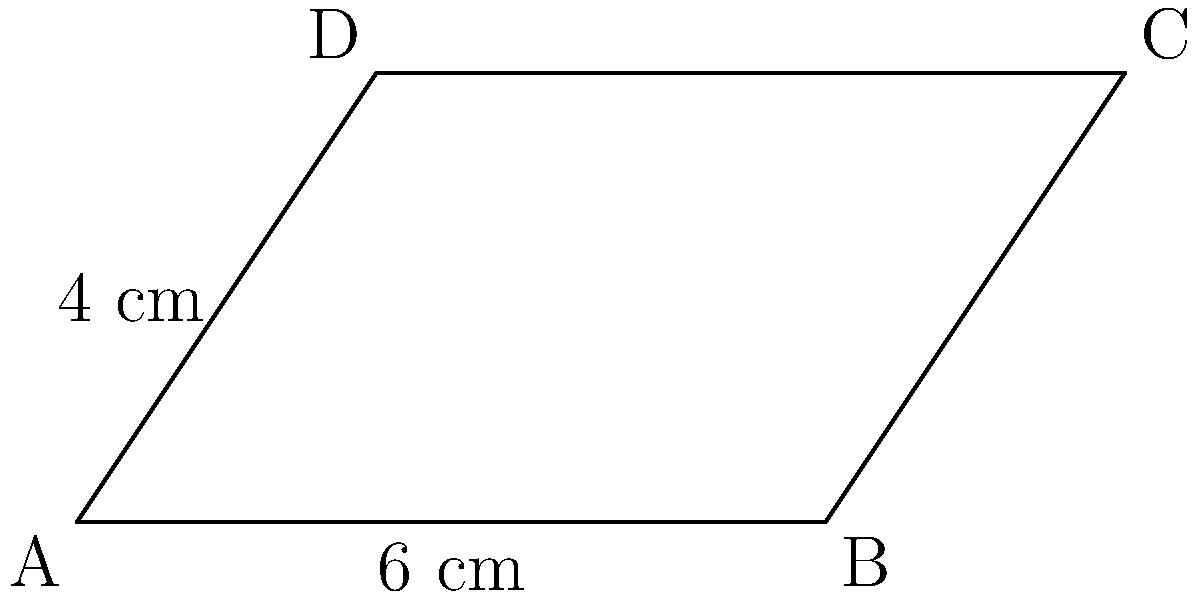As part of your voter education club, you're creating a visual representation of voting district boundaries. You decide to use a parallelogram to simplify the shape. Given the parallelogram ABCD shown above, where the base (AB) is 6 cm and the height (AD) is 4 cm, calculate the area of the parallelogram. How might understanding area calculations help in discussions about fair representation and district sizing? To calculate the area of a parallelogram, we use the formula:

$$ \text{Area} = \text{base} \times \text{height} $$

Given:
- Base (AB) = 6 cm
- Height (AD) = 4 cm

Step 1: Substitute the values into the formula
$$ \text{Area} = 6 \text{ cm} \times 4 \text{ cm} $$

Step 2: Multiply
$$ \text{Area} = 24 \text{ cm}^2 $$

Understanding area calculations in the context of voting districts can help in discussions about fair representation by:
1. Comparing the sizes of different districts
2. Ensuring districts have roughly equal populations
3. Analyzing the efficiency of district shapes in representing communities
4. Discussing the concept of gerrymandering and its impact on representation
Answer: $24 \text{ cm}^2$ 